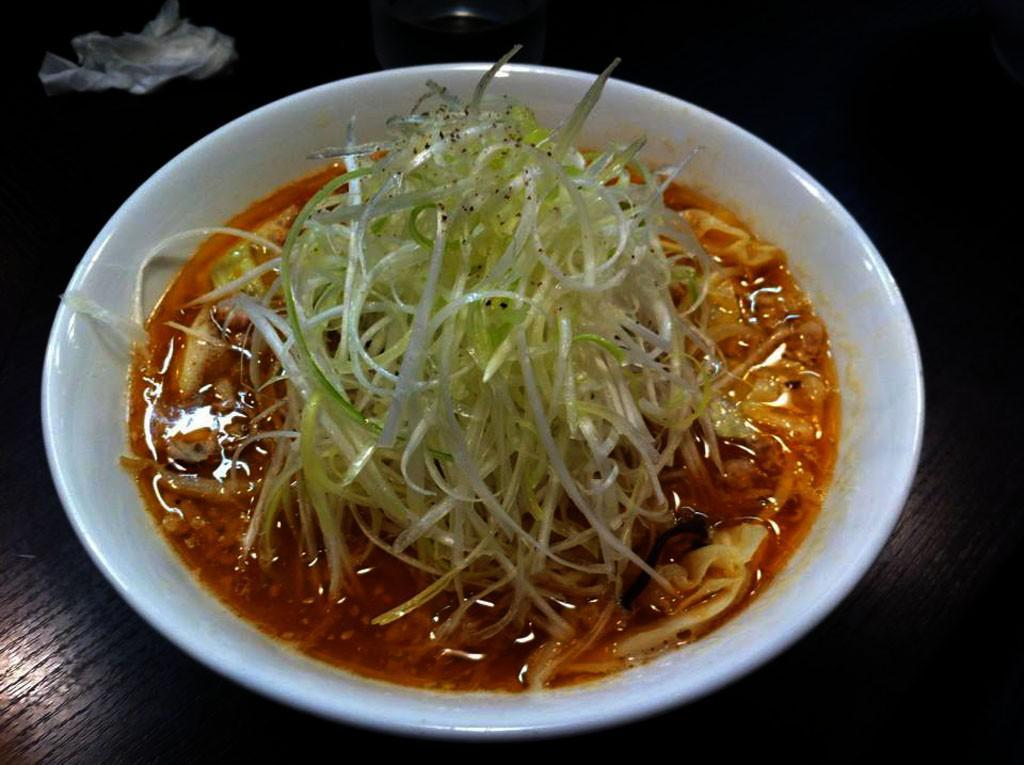What is located on a surface in the image? There is a bowl on a surface in the image. What is inside the bowl? There is food inside the bowl. What else can be seen on the surface besides the bowl? There are objects on the surface. What rule is being enforced by the company in the image? There is no company or rule mentioned in the image; it only shows a bowl with food and objects on a surface. 